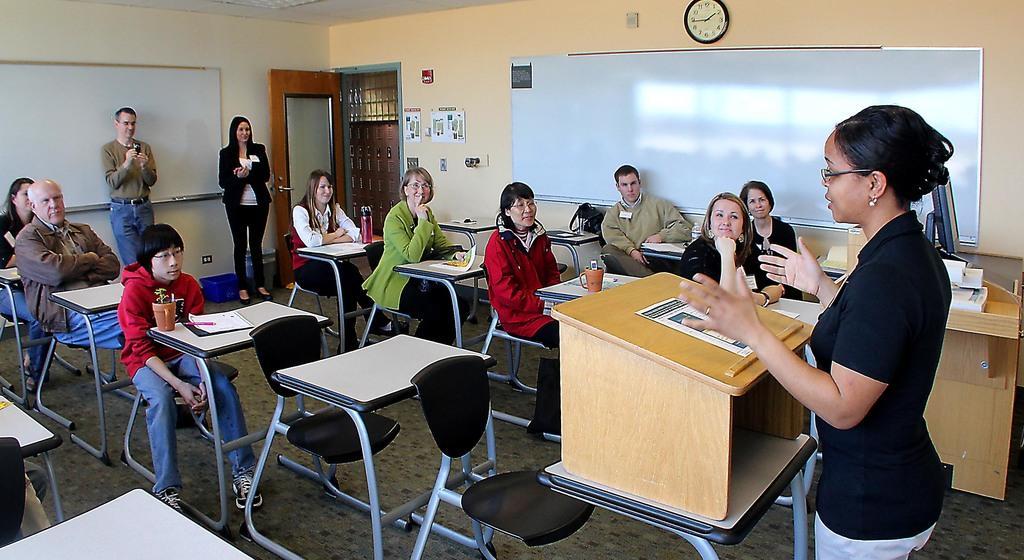Please provide a concise description of this image. This picture is clicked inside the room. There are many people in this room. Among them four are boys. On the right corner of the picture, we see woman in black t-shirt wearing spectacles is talking to the other people in the room. In front of her, we see a table on which paper is placed. We see many study study chairs and tables in this room and to the left top of this picture, we see a white board. Behind that, we see a wall. Next to it, we see a door which is brown in color and on background, we see white board. On top of it, we see a watch. 